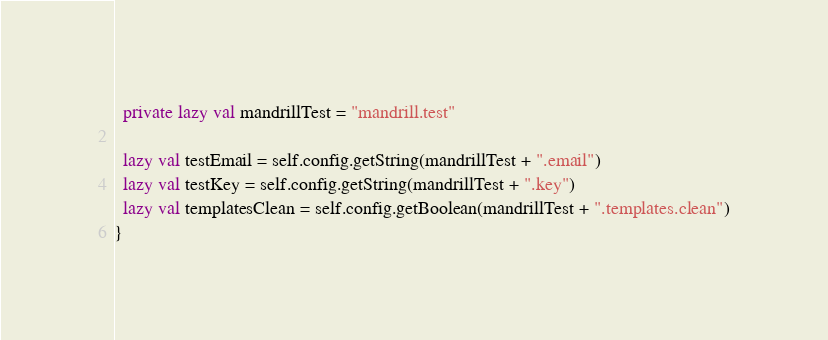<code> <loc_0><loc_0><loc_500><loc_500><_Scala_>  private lazy val mandrillTest = "mandrill.test"

  lazy val testEmail = self.config.getString(mandrillTest + ".email")
  lazy val testKey = self.config.getString(mandrillTest + ".key")
  lazy val templatesClean = self.config.getBoolean(mandrillTest + ".templates.clean")
}</code> 